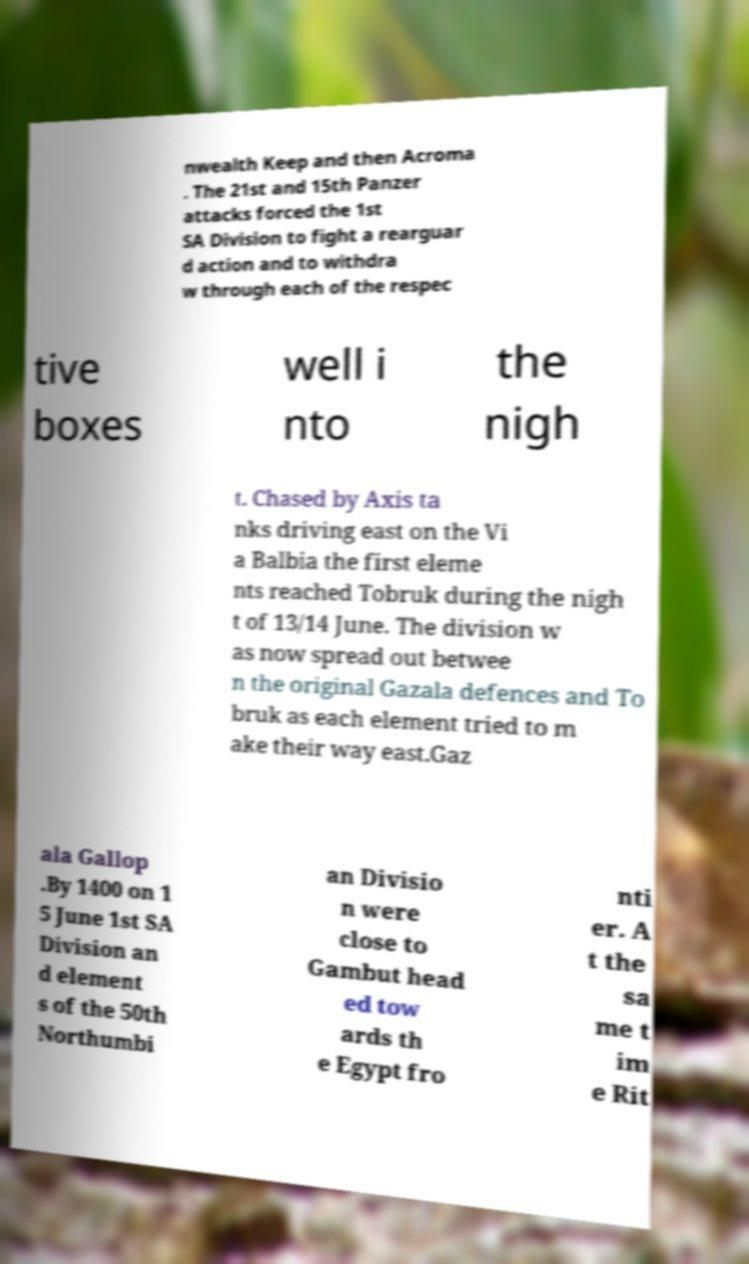Can you accurately transcribe the text from the provided image for me? nwealth Keep and then Acroma . The 21st and 15th Panzer attacks forced the 1st SA Division to fight a rearguar d action and to withdra w through each of the respec tive boxes well i nto the nigh t. Chased by Axis ta nks driving east on the Vi a Balbia the first eleme nts reached Tobruk during the nigh t of 13/14 June. The division w as now spread out betwee n the original Gazala defences and To bruk as each element tried to m ake their way east.Gaz ala Gallop .By 1400 on 1 5 June 1st SA Division an d element s of the 50th Northumbi an Divisio n were close to Gambut head ed tow ards th e Egypt fro nti er. A t the sa me t im e Rit 